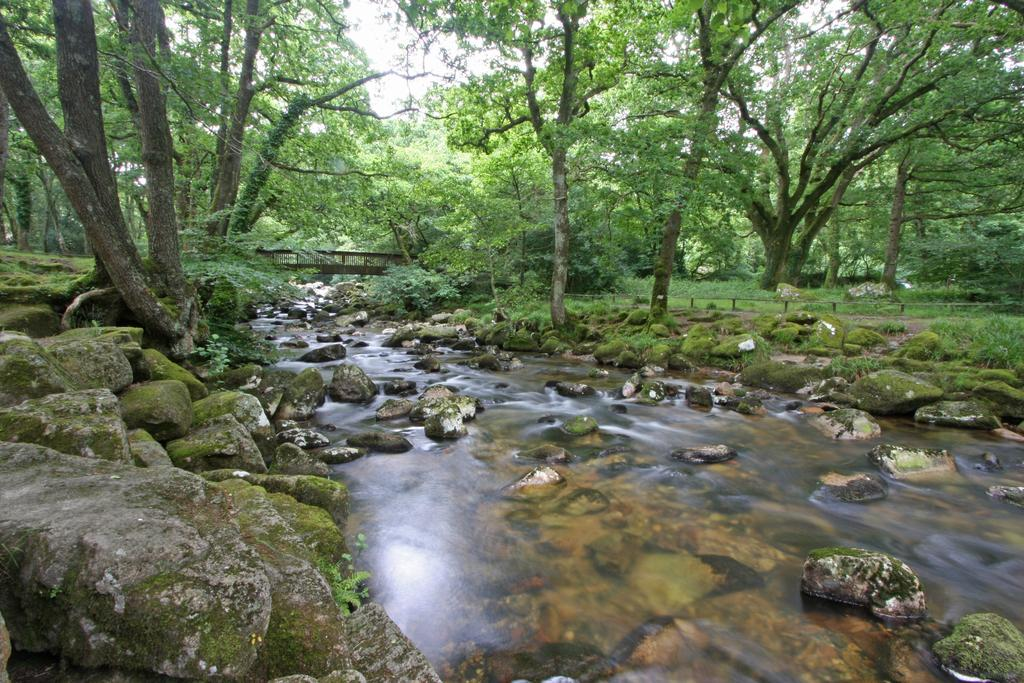What type of natural elements can be seen in the image? There are rocks, running water, plants, and trees in the image. What man-made structure is present in the image? There is a wooden bridge in the image. What part of the natural environment is visible in the image? The sky is visible in the image. What type of wool can be seen in the image? There is no wool present in the image. What is causing the hole in the image? There is no hole present in the image. 